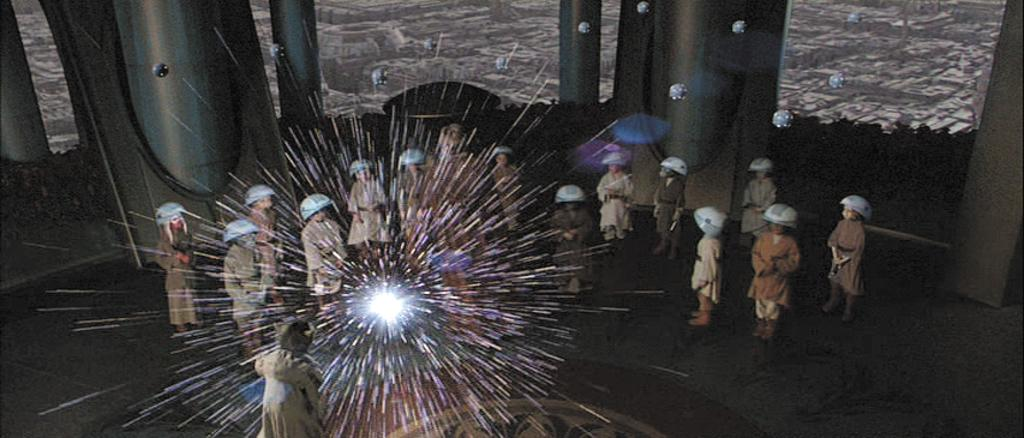What can be seen in the image? There is a group of people in the image. What are the people wearing? The people are wearing brown-colored dresses. What is visible in the background of the image? There is a wall in the background of the image. What color is the wall? The wall is in brown color. How do the people in the image join together to stop the bit from spreading? There is no bit or any indication of it spreading in the image. The people are simply wearing brown-colored dresses and standing in front of a brown wall. 